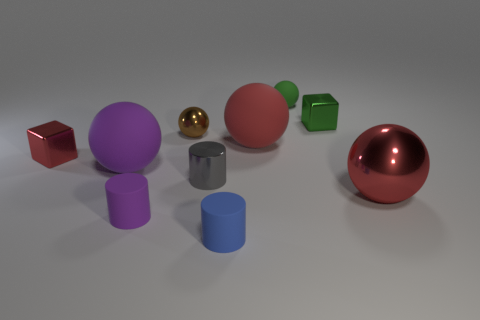How many objects are brown metal things or balls to the right of the big red matte thing?
Offer a very short reply. 3. Does the small red block have the same material as the gray object?
Provide a short and direct response. Yes. Are there an equal number of green metallic cubes that are right of the small green sphere and tiny objects that are on the left side of the purple sphere?
Offer a very short reply. Yes. There is a small purple cylinder; what number of red objects are to the left of it?
Give a very brief answer. 1. What number of objects are either brown spheres or green rubber things?
Ensure brevity in your answer.  2. What number of other objects are the same size as the green shiny thing?
Give a very brief answer. 6. What shape is the big rubber thing behind the tiny block that is in front of the small brown sphere?
Your answer should be compact. Sphere. Are there fewer small blue rubber spheres than small gray metallic objects?
Offer a terse response. Yes. There is a small matte thing behind the red rubber ball; what color is it?
Keep it short and to the point. Green. The object that is both right of the green rubber sphere and in front of the small brown metal thing is made of what material?
Provide a succinct answer. Metal. 